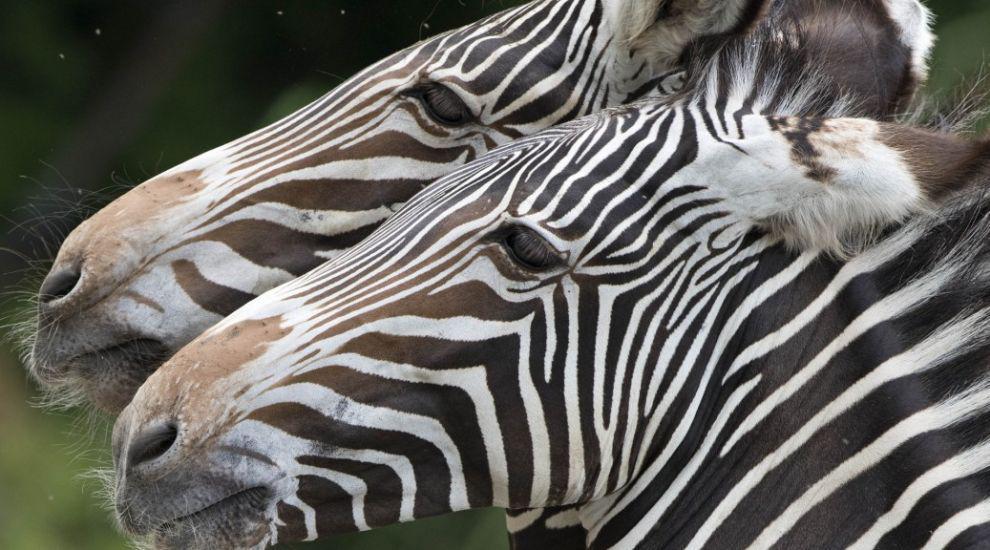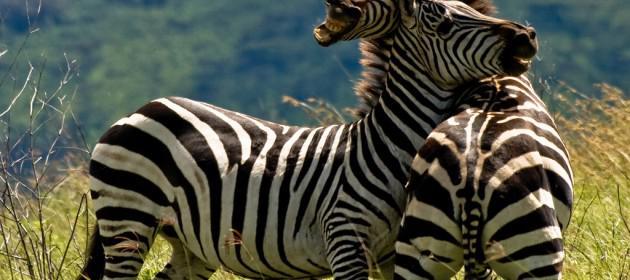The first image is the image on the left, the second image is the image on the right. Assess this claim about the two images: "in at least one image, there are two black and white striped zebra heads facing left.". Correct or not? Answer yes or no. Yes. The first image is the image on the left, the second image is the image on the right. Given the left and right images, does the statement "In one image, one zebra has its head over the back of a zebra with its rear facing the camera and its neck turned so it can look forward." hold true? Answer yes or no. Yes. 